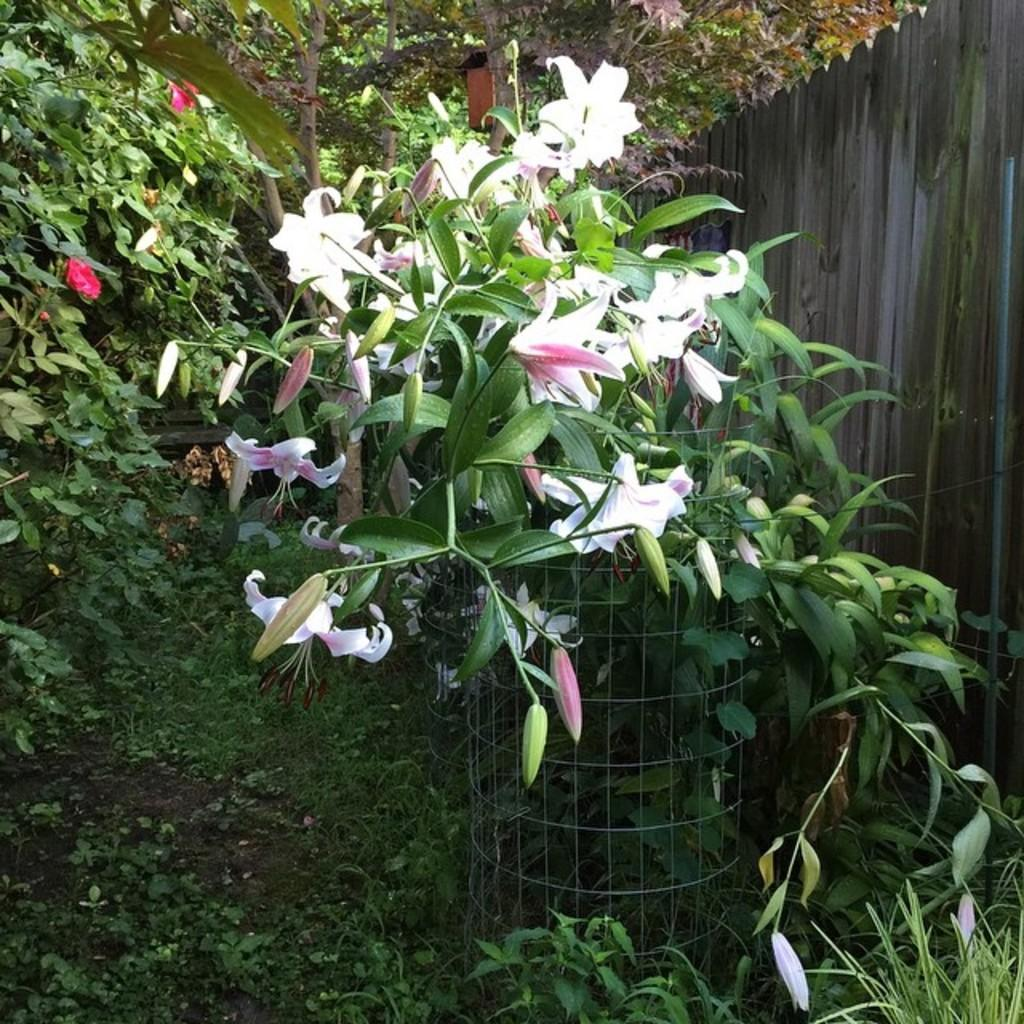What type of living organisms can be seen in the image? Plants can be seen in the image. How are some of the plants protected in the image? There is fencing around one of the plants in the image. What can be seen in the background of the image? Trees are visible in the background of the image. What type of material is used for the wall in the top right of the image? The wall in the top right of the image is made of wood. What type of error can be seen in the image? There is no error present in the image. What is the heart rate of the beast in the image? There is no beast present in the image, and therefore no heart rate can be determined. 